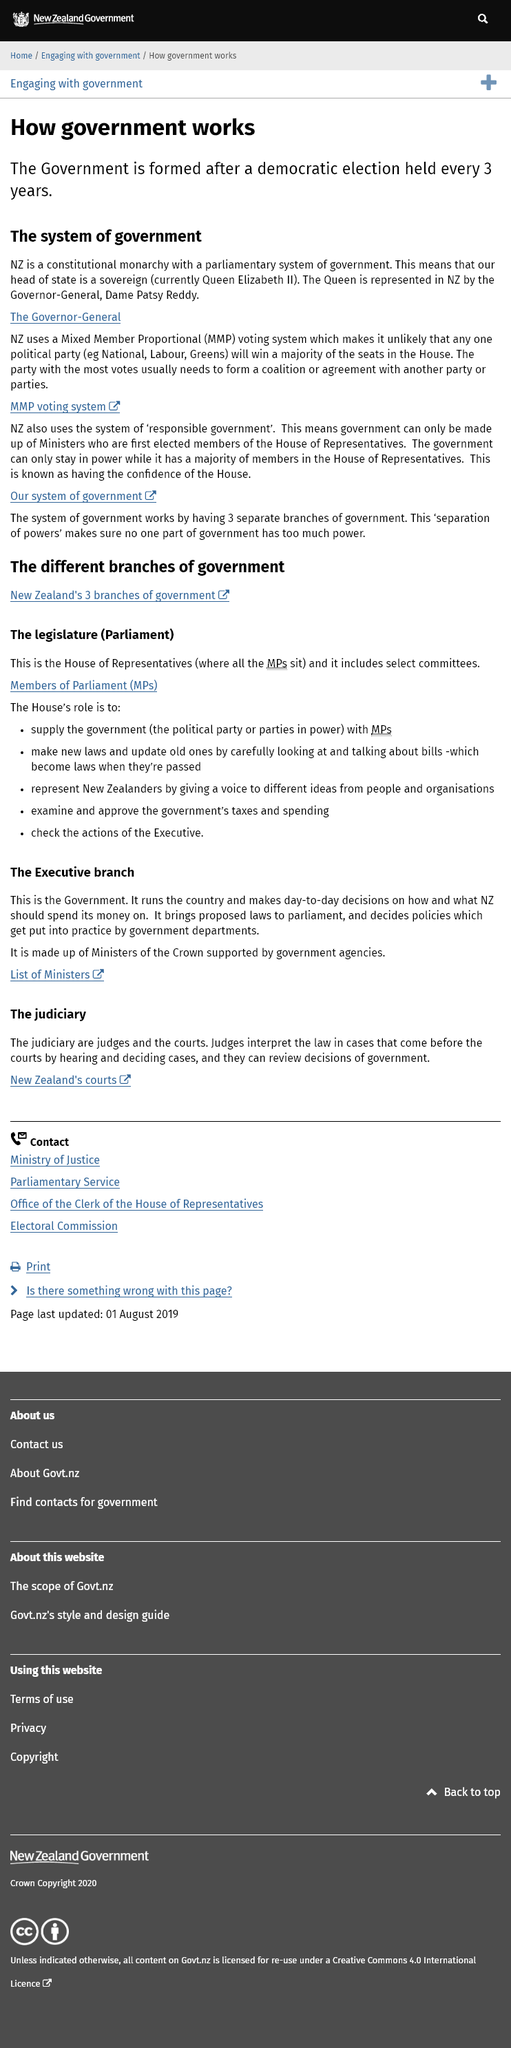Indicate a few pertinent items in this graphic. Yes, New Zealand is a constitutional monarchy. This system of government operates through the functioning of three autonomous and independent branches, each with distinct responsibilities, thereby ensuring a balance of powers and preventing any one branch from becoming too powerful. New Zealand is comprised of three branches of government: the judiciary, the executive branch, and the legislature, which work together to ensure the effective functioning of the country's governance system. New Zealand uses a Mixed Member Proportional voting system for its elections. Judges have the authority to review decisions made by the government. 